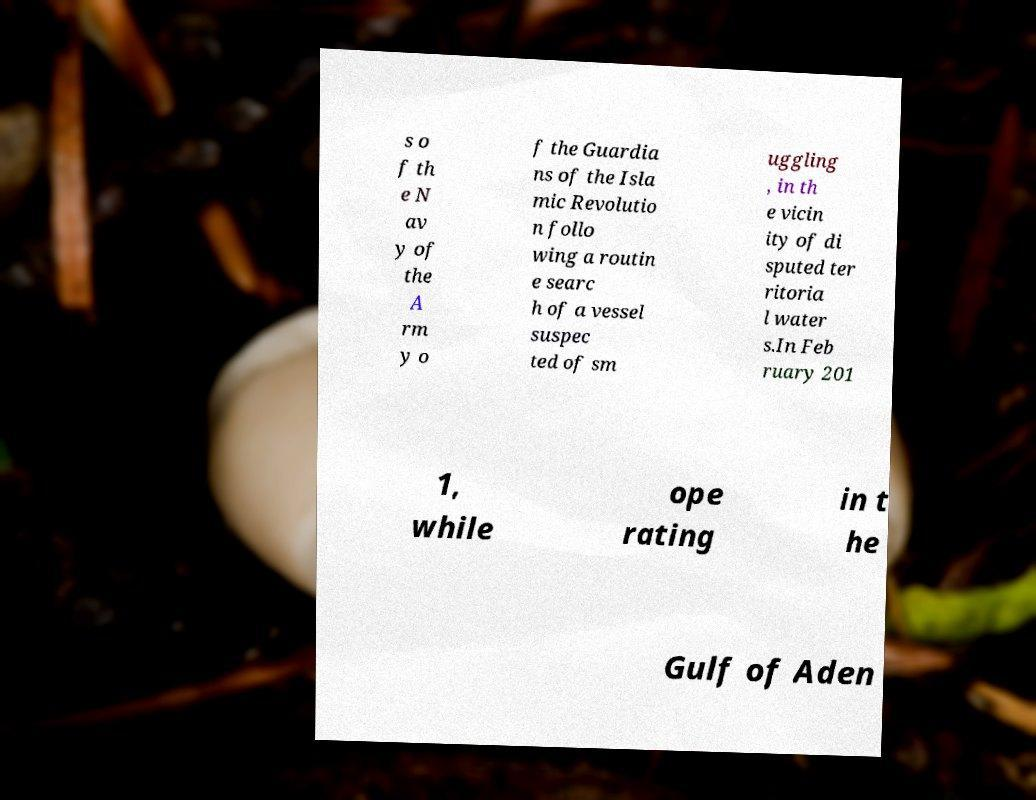Could you assist in decoding the text presented in this image and type it out clearly? s o f th e N av y of the A rm y o f the Guardia ns of the Isla mic Revolutio n follo wing a routin e searc h of a vessel suspec ted of sm uggling , in th e vicin ity of di sputed ter ritoria l water s.In Feb ruary 201 1, while ope rating in t he Gulf of Aden 